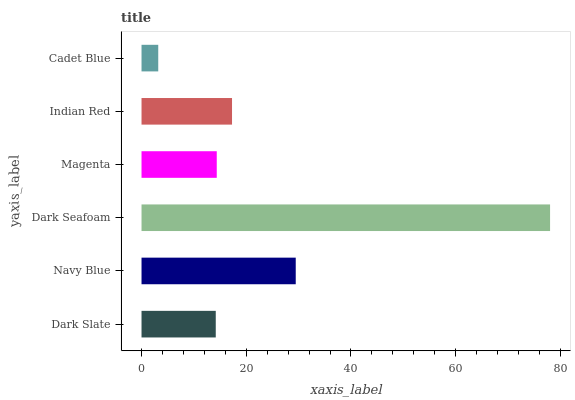Is Cadet Blue the minimum?
Answer yes or no. Yes. Is Dark Seafoam the maximum?
Answer yes or no. Yes. Is Navy Blue the minimum?
Answer yes or no. No. Is Navy Blue the maximum?
Answer yes or no. No. Is Navy Blue greater than Dark Slate?
Answer yes or no. Yes. Is Dark Slate less than Navy Blue?
Answer yes or no. Yes. Is Dark Slate greater than Navy Blue?
Answer yes or no. No. Is Navy Blue less than Dark Slate?
Answer yes or no. No. Is Indian Red the high median?
Answer yes or no. Yes. Is Magenta the low median?
Answer yes or no. Yes. Is Magenta the high median?
Answer yes or no. No. Is Indian Red the low median?
Answer yes or no. No. 